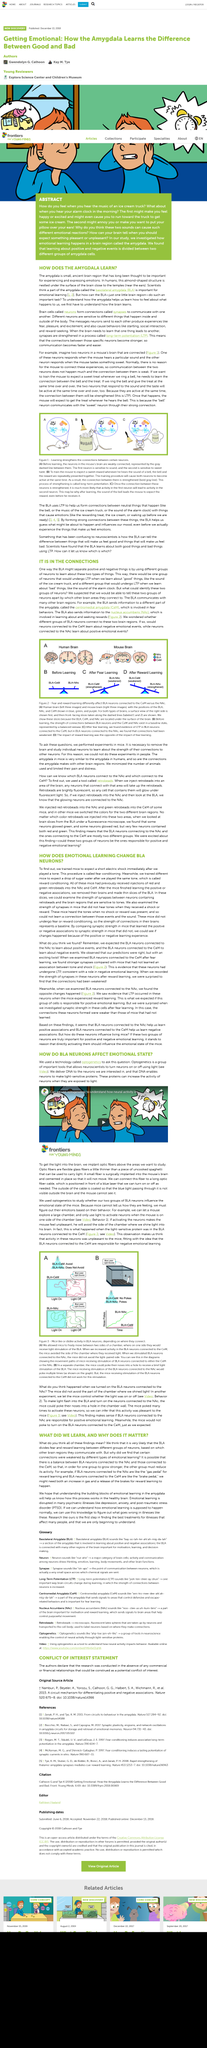Specify some key components in this picture. Optic fibers are flexible glass fibers that are a little thinner than a piece of uncooked spaghetti and can be used to carry light. The study used optogenetics to investigate whether two groups of BLA neurons affect the emotional state of mice. Fear conditioning is the procedure that is called when a subject is immediately given a short electric shock after playing a tone. In this article, LTP stands for Long-term potentiation, which is a process that strengthens the connection between two neurons in the brain. Synapses are the connections formed by neurons to communicate with one another. 